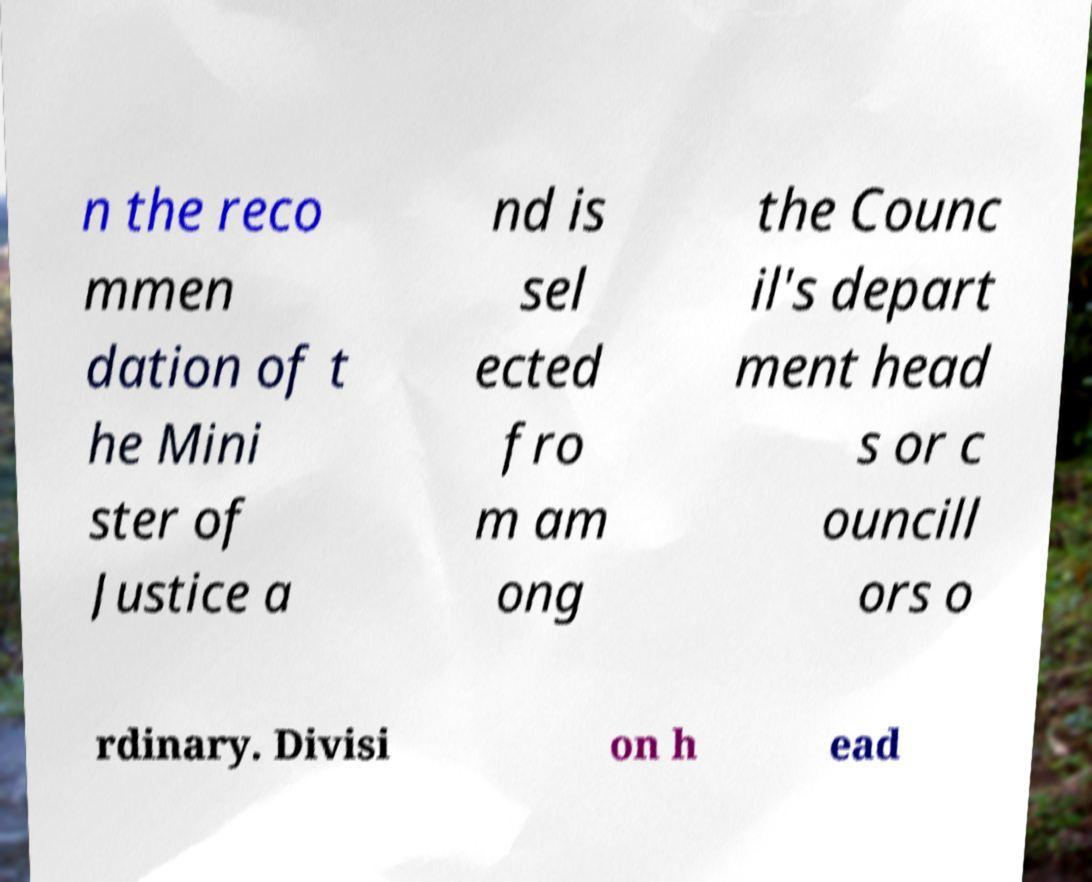Could you extract and type out the text from this image? n the reco mmen dation of t he Mini ster of Justice a nd is sel ected fro m am ong the Counc il's depart ment head s or c ouncill ors o rdinary. Divisi on h ead 